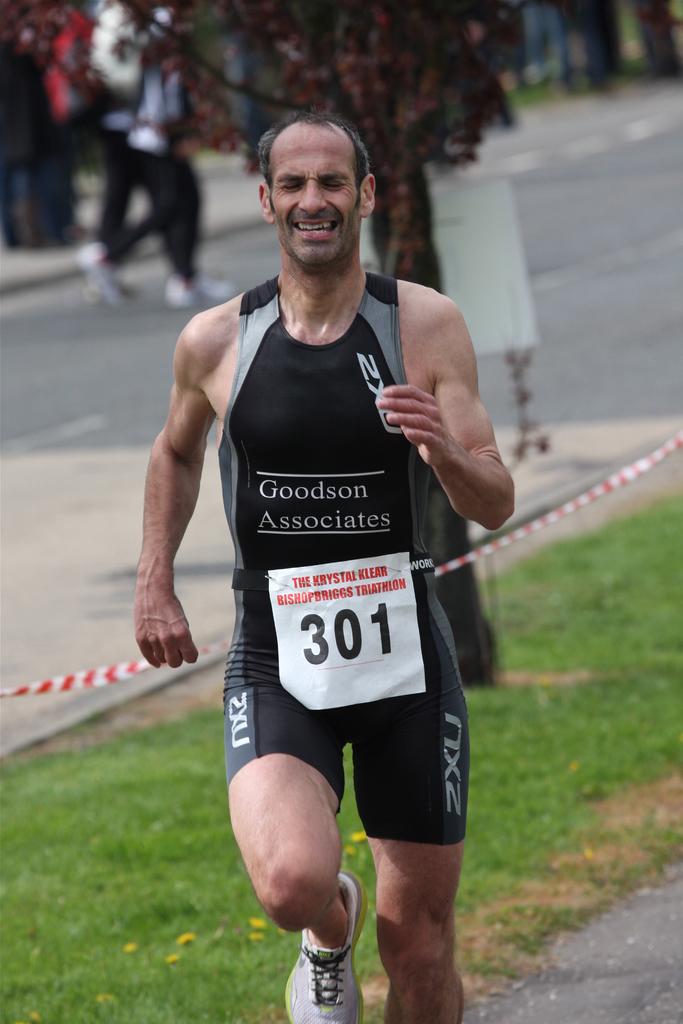What number is this runner?
Your answer should be very brief. 301. What is the man a associate of?
Provide a short and direct response. Goodson. 